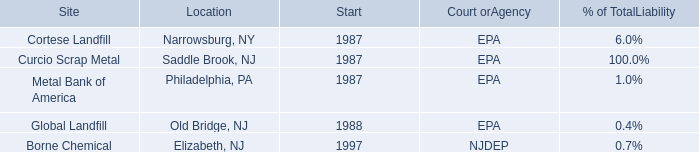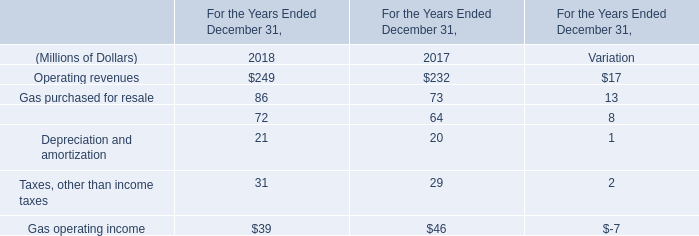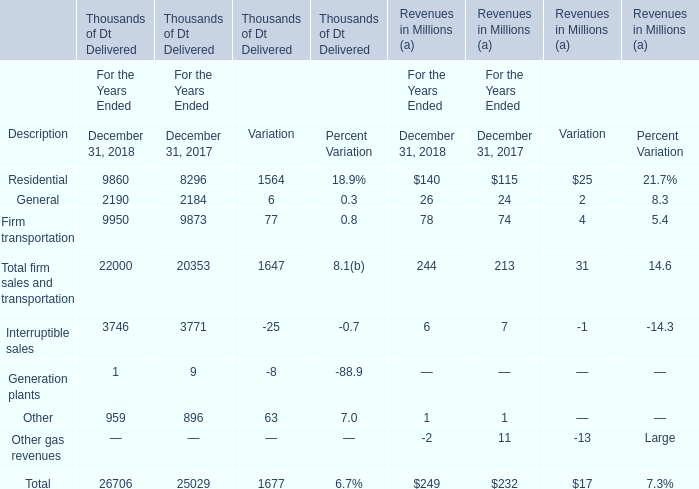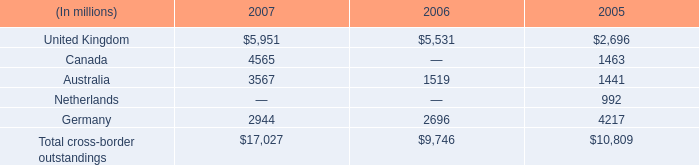what was the percent change in cross-border outstandings in the uk between 2006 and 2007? 
Computations: ((5951 - 5531) / 5531)
Answer: 0.07594. 